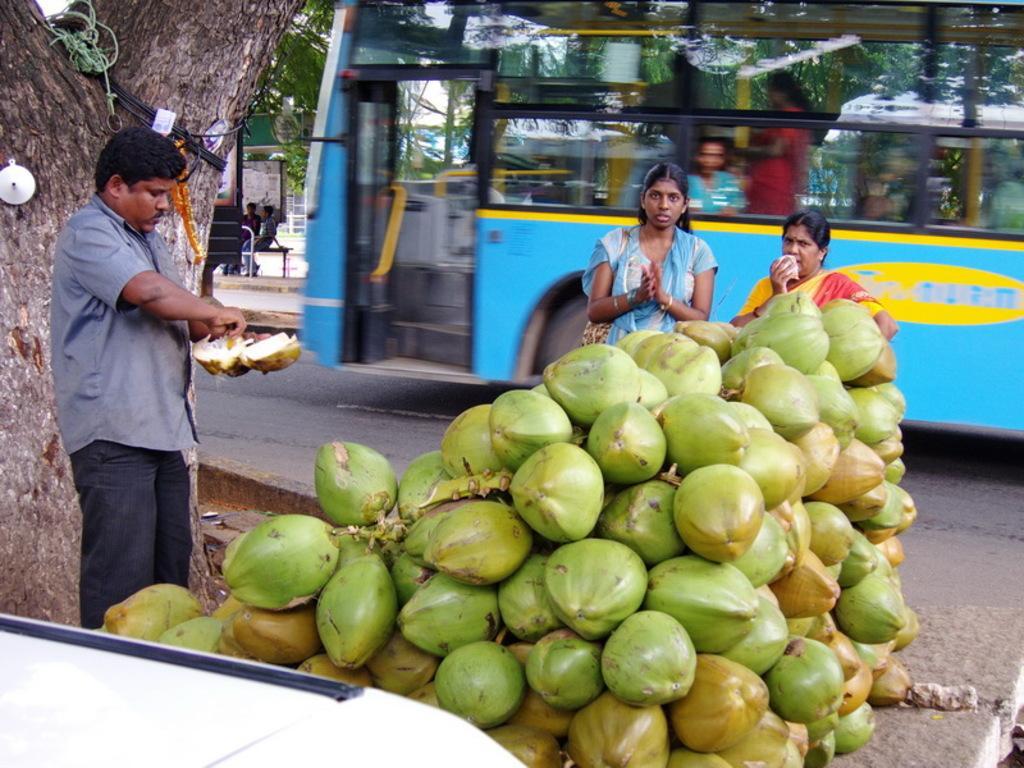How would you summarize this image in a sentence or two? In this image in the front there are coconuts. In the center there are persons standing. On the left side there is a man standing and holding a coconut in his hand. In the background there is a bus with the persons inside it and there are persons sitting on a bench and there are leaves and on the left side there is a tree trunk behind the man which is visible. 